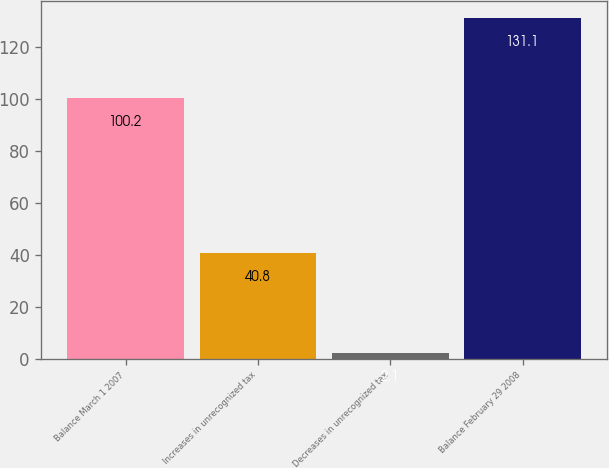Convert chart to OTSL. <chart><loc_0><loc_0><loc_500><loc_500><bar_chart><fcel>Balance March 1 2007<fcel>Increases in unrecognized tax<fcel>Decreases in unrecognized tax<fcel>Balance February 29 2008<nl><fcel>100.2<fcel>40.8<fcel>2.1<fcel>131.1<nl></chart> 